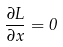Convert formula to latex. <formula><loc_0><loc_0><loc_500><loc_500>\frac { \partial L } { \partial x } = 0</formula> 